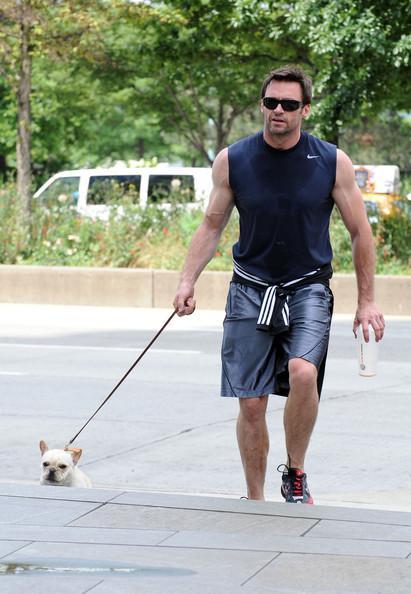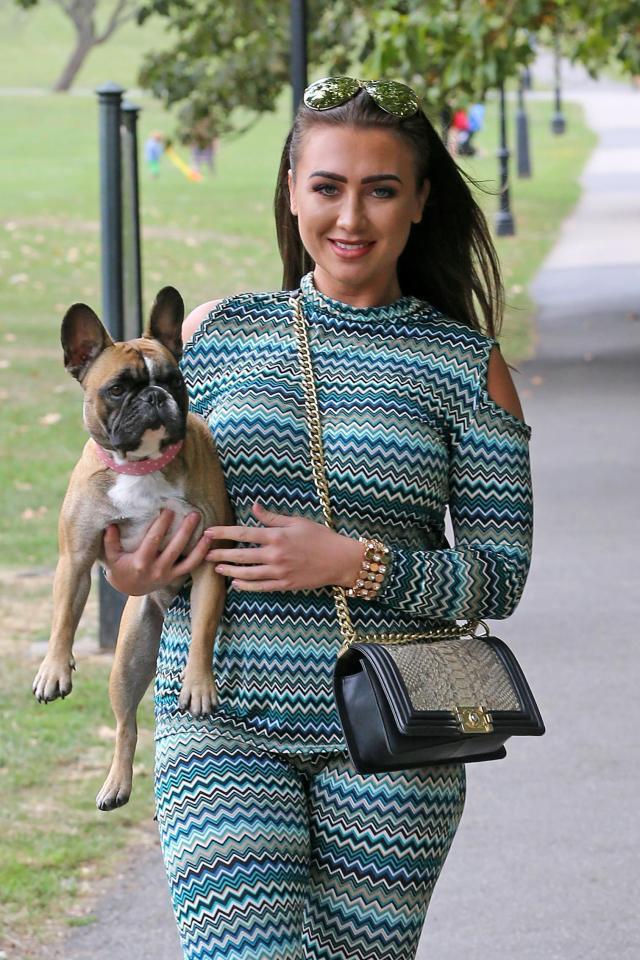The first image is the image on the left, the second image is the image on the right. For the images displayed, is the sentence "Both images in the pair show exactly one woman carrying a dog in her arms." factually correct? Answer yes or no. No. The first image is the image on the left, the second image is the image on the right. Analyze the images presented: Is the assertion "Each image shows just one woman standing with an arm around a dark gray bulldog, and the same woman is shown in both images." valid? Answer yes or no. No. 